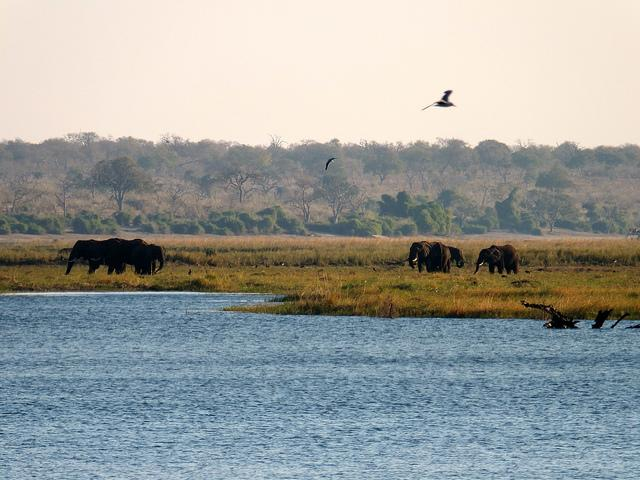Besides Africa what continent can these animals be found naturally on?

Choices:
A) south america
B) asia
C) europe
D) australia asia 